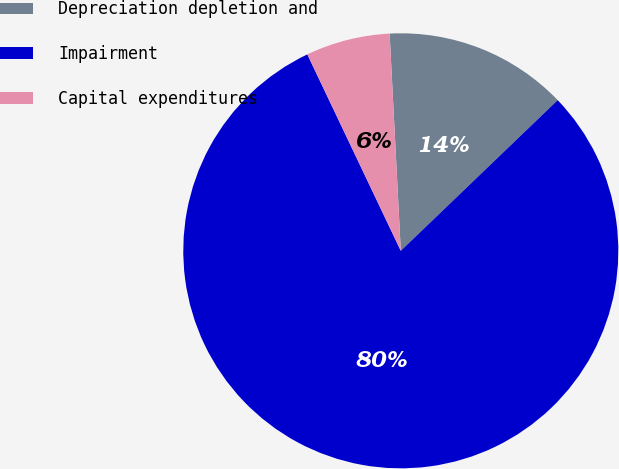Convert chart to OTSL. <chart><loc_0><loc_0><loc_500><loc_500><pie_chart><fcel>Depreciation depletion and<fcel>Impairment<fcel>Capital expenditures<nl><fcel>13.64%<fcel>80.11%<fcel>6.25%<nl></chart> 